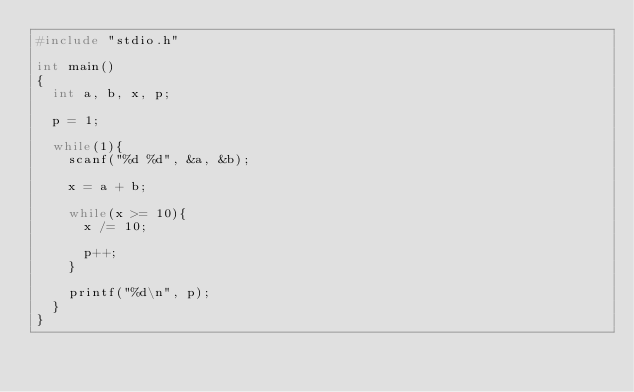<code> <loc_0><loc_0><loc_500><loc_500><_C_>#include "stdio.h"

int main()
{
	int a, b, x, p;

	p = 1;

	while(1){
		scanf("%d %d", &a, &b);

		x = a + b;

		while(x >= 10){
			x /= 10;

			p++;
		}

		printf("%d\n", p);
	}
}</code> 